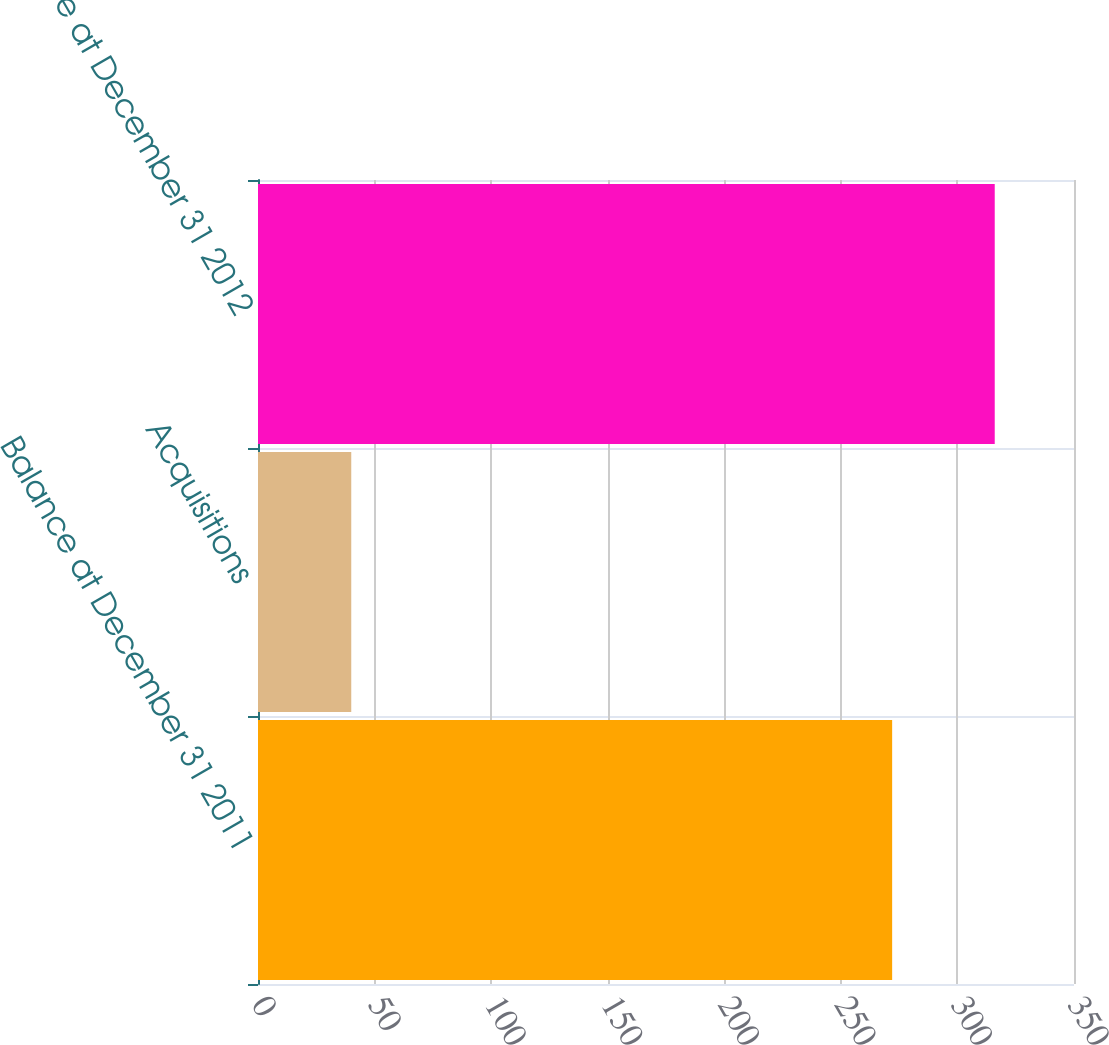Convert chart. <chart><loc_0><loc_0><loc_500><loc_500><bar_chart><fcel>Balance at December 31 2011<fcel>Acquisitions<fcel>Balance at December 31 2012<nl><fcel>272<fcel>40<fcel>316<nl></chart> 